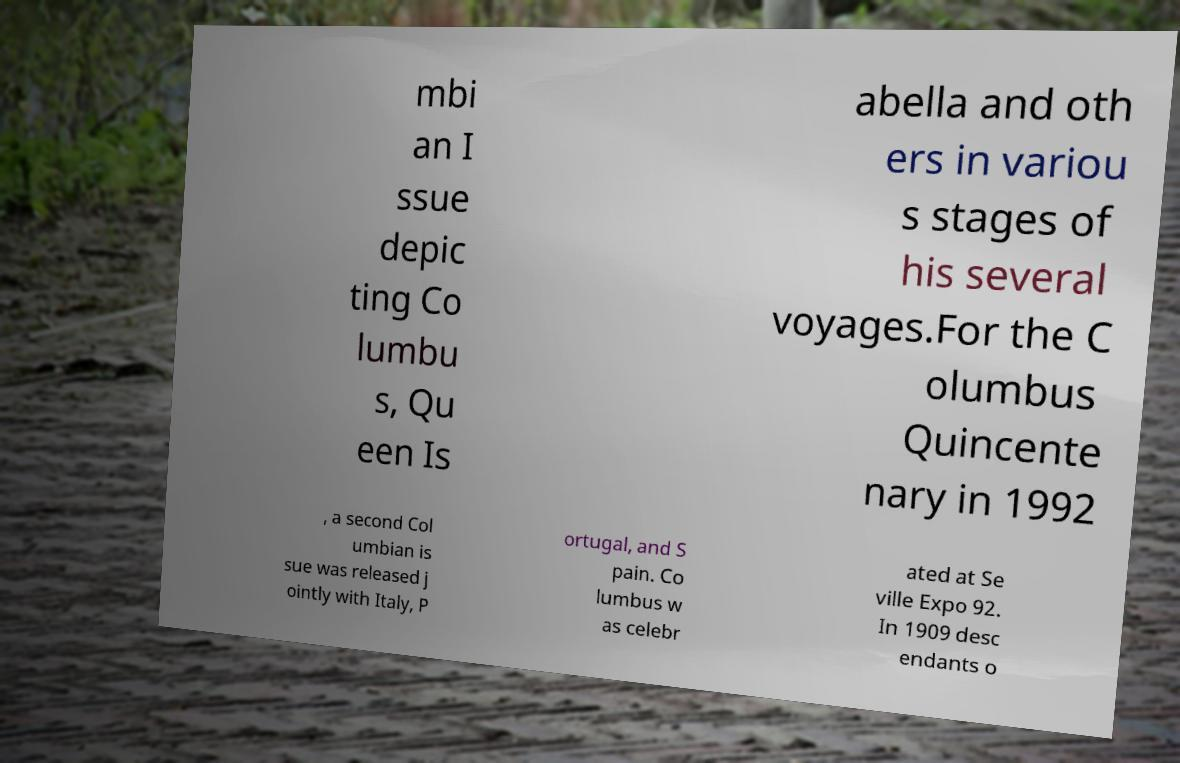I need the written content from this picture converted into text. Can you do that? mbi an I ssue depic ting Co lumbu s, Qu een Is abella and oth ers in variou s stages of his several voyages.For the C olumbus Quincente nary in 1992 , a second Col umbian is sue was released j ointly with Italy, P ortugal, and S pain. Co lumbus w as celebr ated at Se ville Expo 92. In 1909 desc endants o 